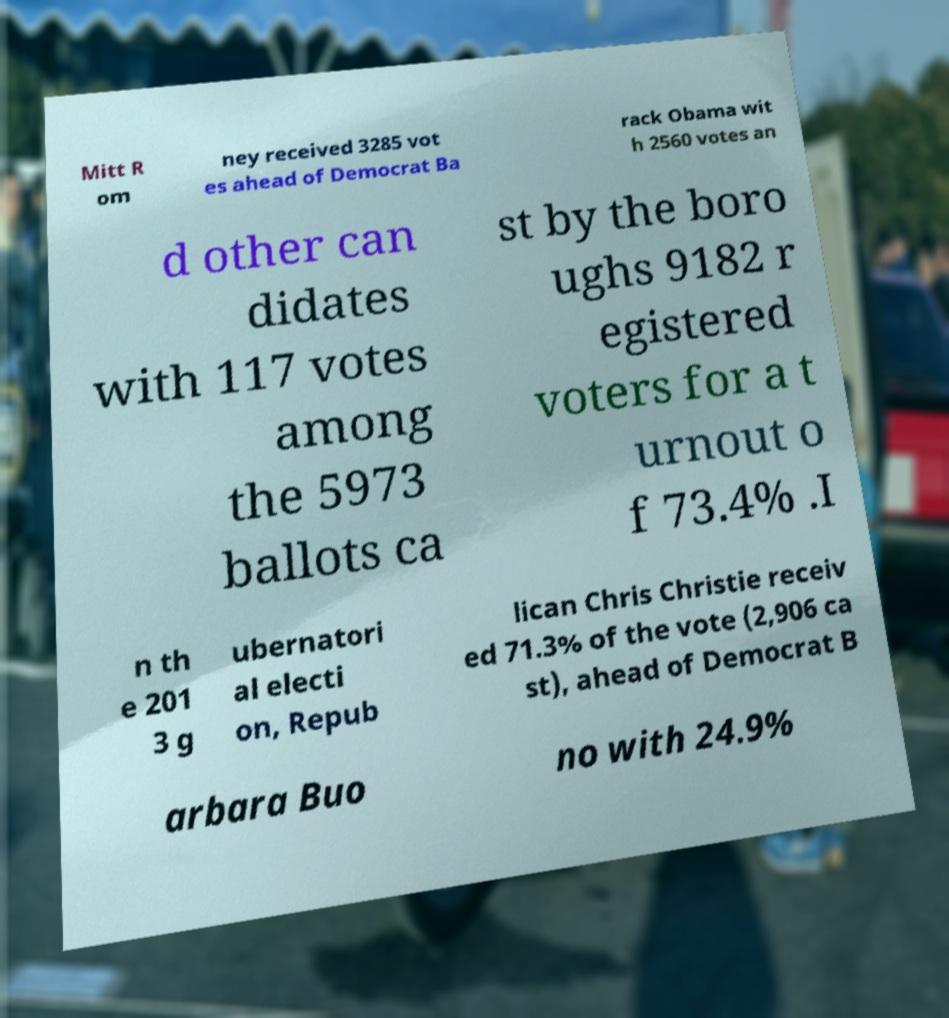Could you extract and type out the text from this image? Mitt R om ney received 3285 vot es ahead of Democrat Ba rack Obama wit h 2560 votes an d other can didates with 117 votes among the 5973 ballots ca st by the boro ughs 9182 r egistered voters for a t urnout o f 73.4% .I n th e 201 3 g ubernatori al electi on, Repub lican Chris Christie receiv ed 71.3% of the vote (2,906 ca st), ahead of Democrat B arbara Buo no with 24.9% 